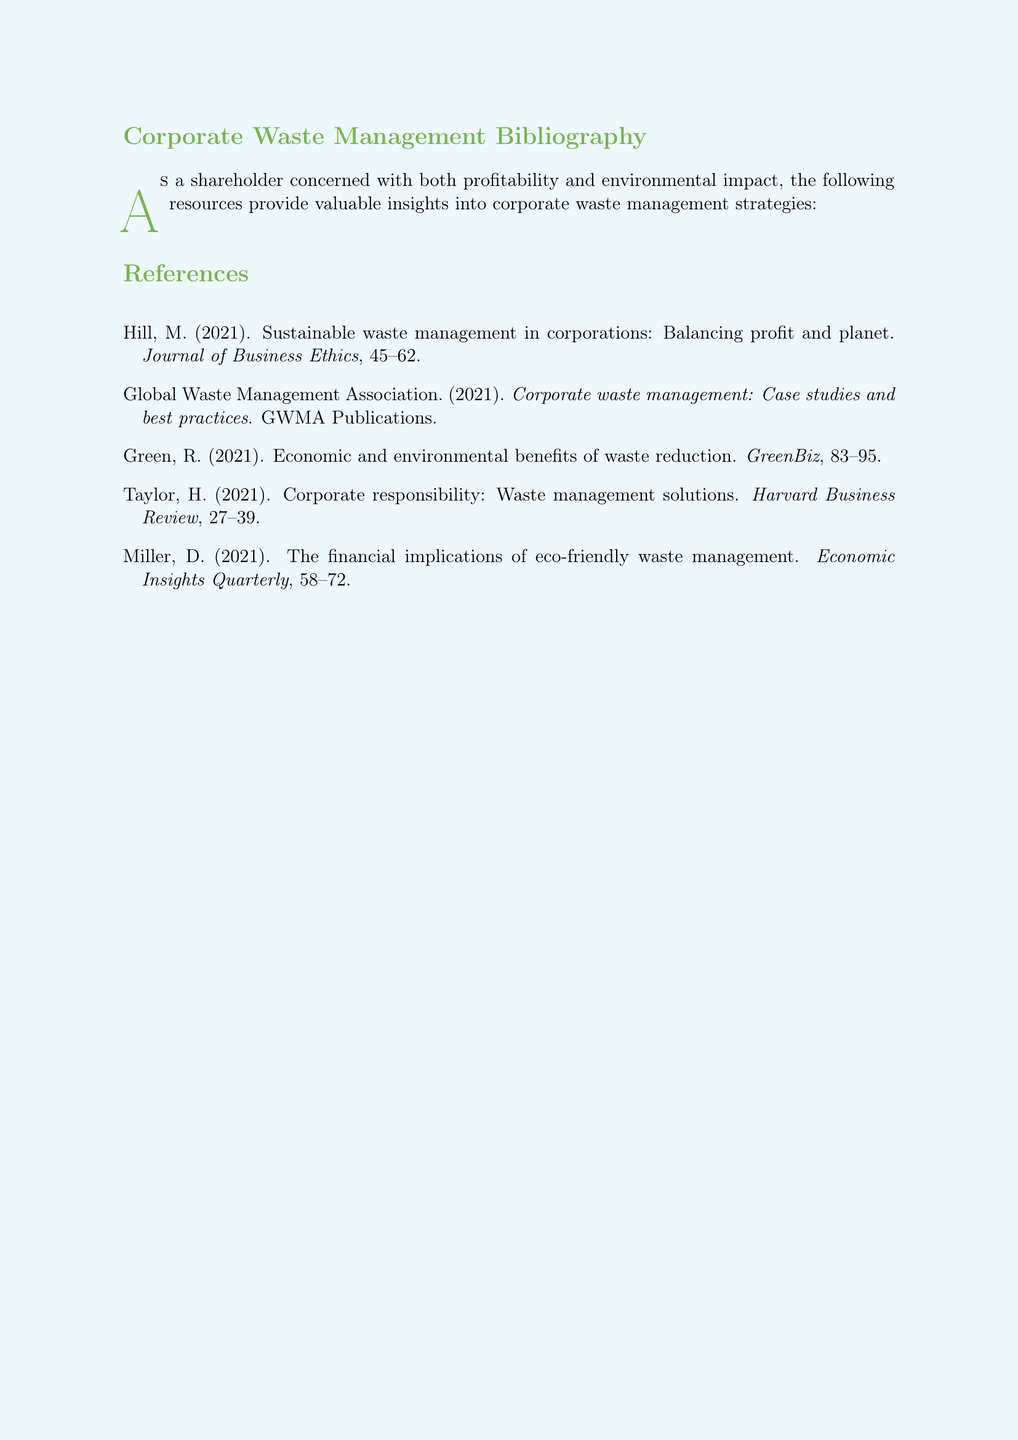What is the title of Hill's 2021 paper? The title is found under Hill's citation, which provides details about his 2021 paper.
Answer: Sustainable waste management in corporations: Balancing profit and planet Who published the document titled "Corporate waste management: Case studies and best practices"? The publication source is listed next to the title in the Global Waste Management Association citation.
Answer: GWMA Publications Which journal includes the article by Green in 2021? The journal name is indicated in the citation provided under Green's entry.
Answer: GreenBiz What are the page numbers for Taylor's article? The page range is provided in the citation entry for Taylor's article, presenting the relevant information.
Answer: 27--39 How many authors are listed in the bibliography? The total number of authors can be determined by counting the distinct entries in the bibliography.
Answer: 5 What year does Miller's research focus on? The year is part of Miller's citation, indicating when the study was published.
Answer: 2021 What type of document is this bibliography formatted as? The document is explicitly stated to be in a particular style, outlining its academic format.
Answer: Bibliography Identify one topic covered by the sources listed. Each source covers different aspects of corporate waste management, including the theme of balancing profit with environmental considerations.
Answer: Waste management strategies What is the subtitle of Green's paper? The subtitle can be identified from the citation details, summarizing the focus of the paper.
Answer: Economic and environmental benefits of waste reduction 